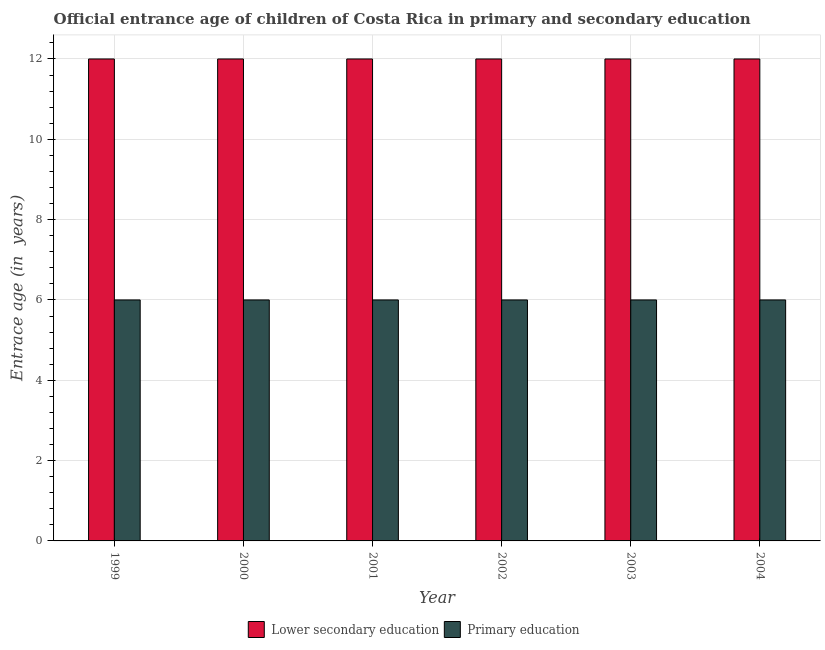Are the number of bars per tick equal to the number of legend labels?
Provide a succinct answer. Yes. How many bars are there on the 4th tick from the right?
Your response must be concise. 2. In how many cases, is the number of bars for a given year not equal to the number of legend labels?
Give a very brief answer. 0. What is the entrance age of children in lower secondary education in 2004?
Offer a terse response. 12. Across all years, what is the maximum entrance age of children in lower secondary education?
Provide a succinct answer. 12. Across all years, what is the minimum entrance age of children in lower secondary education?
Give a very brief answer. 12. What is the total entrance age of chiildren in primary education in the graph?
Give a very brief answer. 36. What is the difference between the entrance age of children in lower secondary education in 2002 and that in 2004?
Offer a very short reply. 0. What is the difference between the entrance age of children in lower secondary education in 1999 and the entrance age of chiildren in primary education in 2000?
Ensure brevity in your answer.  0. In the year 2004, what is the difference between the entrance age of chiildren in primary education and entrance age of children in lower secondary education?
Keep it short and to the point. 0. What is the ratio of the entrance age of children in lower secondary education in 2000 to that in 2002?
Your response must be concise. 1. Is the difference between the entrance age of chiildren in primary education in 1999 and 2003 greater than the difference between the entrance age of children in lower secondary education in 1999 and 2003?
Provide a succinct answer. No. Is the sum of the entrance age of children in lower secondary education in 2001 and 2004 greater than the maximum entrance age of chiildren in primary education across all years?
Offer a terse response. Yes. What does the 2nd bar from the right in 2004 represents?
Provide a succinct answer. Lower secondary education. How many bars are there?
Give a very brief answer. 12. Are all the bars in the graph horizontal?
Offer a very short reply. No. Are the values on the major ticks of Y-axis written in scientific E-notation?
Ensure brevity in your answer.  No. Does the graph contain grids?
Your response must be concise. Yes. Where does the legend appear in the graph?
Your answer should be very brief. Bottom center. What is the title of the graph?
Offer a terse response. Official entrance age of children of Costa Rica in primary and secondary education. What is the label or title of the Y-axis?
Give a very brief answer. Entrace age (in  years). What is the Entrace age (in  years) in Lower secondary education in 1999?
Make the answer very short. 12. What is the Entrace age (in  years) of Primary education in 2000?
Your answer should be compact. 6. What is the Entrace age (in  years) in Lower secondary education in 2003?
Keep it short and to the point. 12. What is the Entrace age (in  years) of Primary education in 2003?
Your answer should be compact. 6. Across all years, what is the maximum Entrace age (in  years) of Primary education?
Ensure brevity in your answer.  6. What is the difference between the Entrace age (in  years) in Primary education in 1999 and that in 2000?
Keep it short and to the point. 0. What is the difference between the Entrace age (in  years) of Primary education in 1999 and that in 2001?
Make the answer very short. 0. What is the difference between the Entrace age (in  years) of Lower secondary education in 1999 and that in 2002?
Keep it short and to the point. 0. What is the difference between the Entrace age (in  years) of Primary education in 1999 and that in 2002?
Offer a very short reply. 0. What is the difference between the Entrace age (in  years) of Lower secondary education in 1999 and that in 2003?
Keep it short and to the point. 0. What is the difference between the Entrace age (in  years) in Primary education in 1999 and that in 2003?
Your answer should be very brief. 0. What is the difference between the Entrace age (in  years) of Primary education in 2000 and that in 2001?
Make the answer very short. 0. What is the difference between the Entrace age (in  years) of Lower secondary education in 2001 and that in 2002?
Give a very brief answer. 0. What is the difference between the Entrace age (in  years) in Lower secondary education in 2001 and that in 2003?
Give a very brief answer. 0. What is the difference between the Entrace age (in  years) in Primary education in 2001 and that in 2003?
Keep it short and to the point. 0. What is the difference between the Entrace age (in  years) in Primary education in 2001 and that in 2004?
Give a very brief answer. 0. What is the difference between the Entrace age (in  years) of Primary education in 2002 and that in 2003?
Give a very brief answer. 0. What is the difference between the Entrace age (in  years) of Lower secondary education in 2003 and that in 2004?
Offer a very short reply. 0. What is the difference between the Entrace age (in  years) in Primary education in 2003 and that in 2004?
Offer a terse response. 0. What is the difference between the Entrace age (in  years) in Lower secondary education in 1999 and the Entrace age (in  years) in Primary education in 2000?
Your response must be concise. 6. What is the difference between the Entrace age (in  years) in Lower secondary education in 1999 and the Entrace age (in  years) in Primary education in 2001?
Your answer should be compact. 6. What is the difference between the Entrace age (in  years) of Lower secondary education in 2000 and the Entrace age (in  years) of Primary education in 2003?
Make the answer very short. 6. What is the difference between the Entrace age (in  years) in Lower secondary education in 2001 and the Entrace age (in  years) in Primary education in 2003?
Your response must be concise. 6. What is the difference between the Entrace age (in  years) in Lower secondary education in 2002 and the Entrace age (in  years) in Primary education in 2004?
Offer a terse response. 6. What is the average Entrace age (in  years) in Lower secondary education per year?
Your response must be concise. 12. What is the average Entrace age (in  years) in Primary education per year?
Make the answer very short. 6. In the year 1999, what is the difference between the Entrace age (in  years) of Lower secondary education and Entrace age (in  years) of Primary education?
Offer a very short reply. 6. In the year 2001, what is the difference between the Entrace age (in  years) in Lower secondary education and Entrace age (in  years) in Primary education?
Offer a terse response. 6. In the year 2002, what is the difference between the Entrace age (in  years) in Lower secondary education and Entrace age (in  years) in Primary education?
Offer a very short reply. 6. What is the ratio of the Entrace age (in  years) in Lower secondary education in 1999 to that in 2000?
Offer a very short reply. 1. What is the ratio of the Entrace age (in  years) of Lower secondary education in 1999 to that in 2001?
Ensure brevity in your answer.  1. What is the ratio of the Entrace age (in  years) in Lower secondary education in 1999 to that in 2003?
Keep it short and to the point. 1. What is the ratio of the Entrace age (in  years) of Primary education in 1999 to that in 2003?
Your answer should be compact. 1. What is the ratio of the Entrace age (in  years) in Lower secondary education in 2000 to that in 2001?
Offer a terse response. 1. What is the ratio of the Entrace age (in  years) of Primary education in 2000 to that in 2001?
Offer a terse response. 1. What is the ratio of the Entrace age (in  years) of Primary education in 2000 to that in 2002?
Provide a short and direct response. 1. What is the ratio of the Entrace age (in  years) in Primary education in 2000 to that in 2003?
Make the answer very short. 1. What is the ratio of the Entrace age (in  years) of Primary education in 2000 to that in 2004?
Your answer should be very brief. 1. What is the ratio of the Entrace age (in  years) of Lower secondary education in 2001 to that in 2002?
Your answer should be compact. 1. What is the ratio of the Entrace age (in  years) in Primary education in 2001 to that in 2002?
Provide a succinct answer. 1. What is the ratio of the Entrace age (in  years) in Primary education in 2001 to that in 2003?
Ensure brevity in your answer.  1. What is the ratio of the Entrace age (in  years) of Lower secondary education in 2001 to that in 2004?
Your response must be concise. 1. What is the ratio of the Entrace age (in  years) of Primary education in 2001 to that in 2004?
Keep it short and to the point. 1. What is the ratio of the Entrace age (in  years) in Lower secondary education in 2002 to that in 2003?
Ensure brevity in your answer.  1. What is the ratio of the Entrace age (in  years) of Lower secondary education in 2003 to that in 2004?
Your answer should be compact. 1. What is the ratio of the Entrace age (in  years) of Primary education in 2003 to that in 2004?
Your response must be concise. 1. 